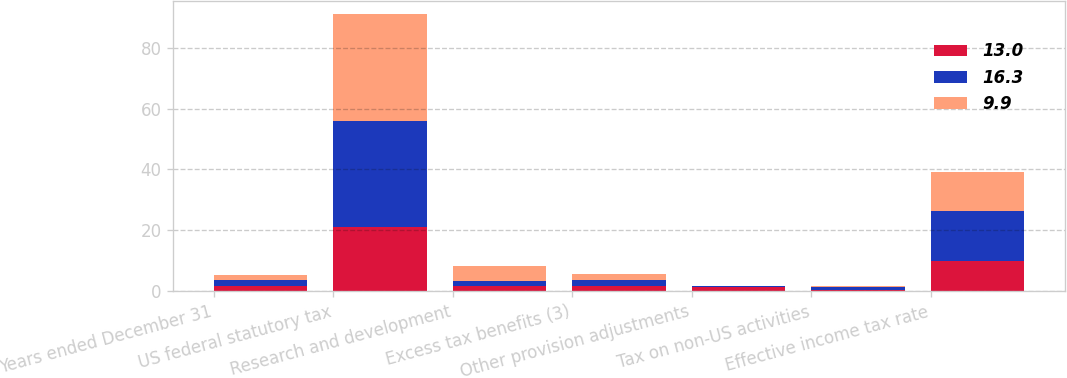<chart> <loc_0><loc_0><loc_500><loc_500><stacked_bar_chart><ecel><fcel>Years ended December 31<fcel>US federal statutory tax<fcel>Research and development<fcel>Excess tax benefits (3)<fcel>Other provision adjustments<fcel>Tax on non-US activities<fcel>Effective income tax rate<nl><fcel>13<fcel>1.8<fcel>21<fcel>1.8<fcel>1.6<fcel>1.3<fcel>0.3<fcel>9.9<nl><fcel>16.3<fcel>1.8<fcel>35<fcel>1.6<fcel>2.1<fcel>0.2<fcel>0.9<fcel>16.3<nl><fcel>9.9<fcel>1.8<fcel>35<fcel>5<fcel>1.8<fcel>0.3<fcel>0.5<fcel>13<nl></chart> 